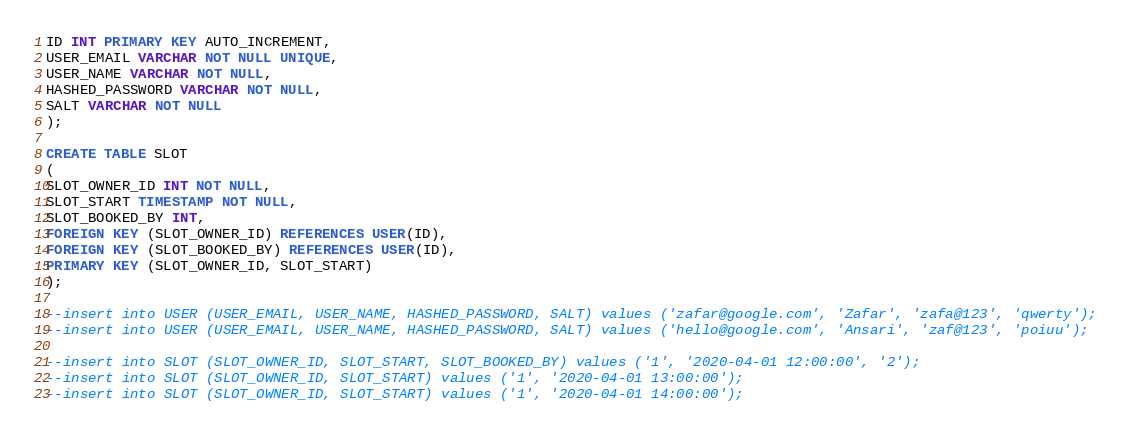<code> <loc_0><loc_0><loc_500><loc_500><_SQL_>ID INT PRIMARY KEY AUTO_INCREMENT,
USER_EMAIL VARCHAR NOT NULL UNIQUE,
USER_NAME VARCHAR NOT NULL,
HASHED_PASSWORD VARCHAR NOT NULL,
SALT VARCHAR NOT NULL
);

CREATE TABLE SLOT
(
SLOT_OWNER_ID INT NOT NULL,
SLOT_START TIMESTAMP NOT NULL,
SLOT_BOOKED_BY INT,
FOREIGN KEY (SLOT_OWNER_ID) REFERENCES USER(ID),
FOREIGN KEY (SLOT_BOOKED_BY) REFERENCES USER(ID),
PRIMARY KEY (SLOT_OWNER_ID, SLOT_START)
);

--insert into USER (USER_EMAIL, USER_NAME, HASHED_PASSWORD, SALT) values ('zafar@google.com', 'Zafar', 'zafa@123', 'qwerty');
--insert into USER (USER_EMAIL, USER_NAME, HASHED_PASSWORD, SALT) values ('hello@google.com', 'Ansari', 'zaf@123', 'poiuu');

--insert into SLOT (SLOT_OWNER_ID, SLOT_START, SLOT_BOOKED_BY) values ('1', '2020-04-01 12:00:00', '2');
--insert into SLOT (SLOT_OWNER_ID, SLOT_START) values ('1', '2020-04-01 13:00:00');
--insert into SLOT (SLOT_OWNER_ID, SLOT_START) values ('1', '2020-04-01 14:00:00');
</code> 